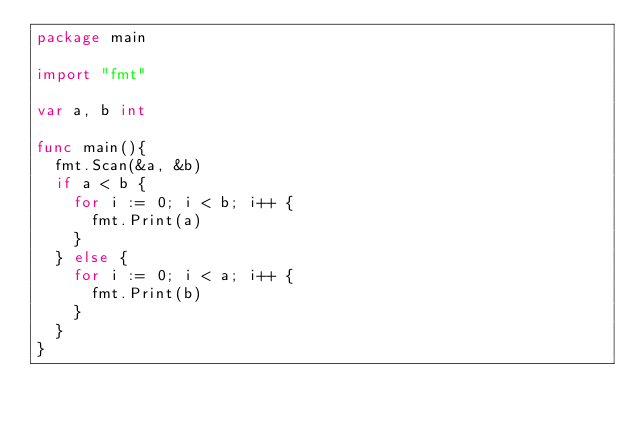Convert code to text. <code><loc_0><loc_0><loc_500><loc_500><_Go_>package main

import "fmt"

var a, b int

func main(){
  fmt.Scan(&a, &b)
  if a < b {
    for i := 0; i < b; i++ {
      fmt.Print(a)  
    }
  } else {
    for i := 0; i < a; i++ {
      fmt.Print(b)  
    }
  }
}</code> 